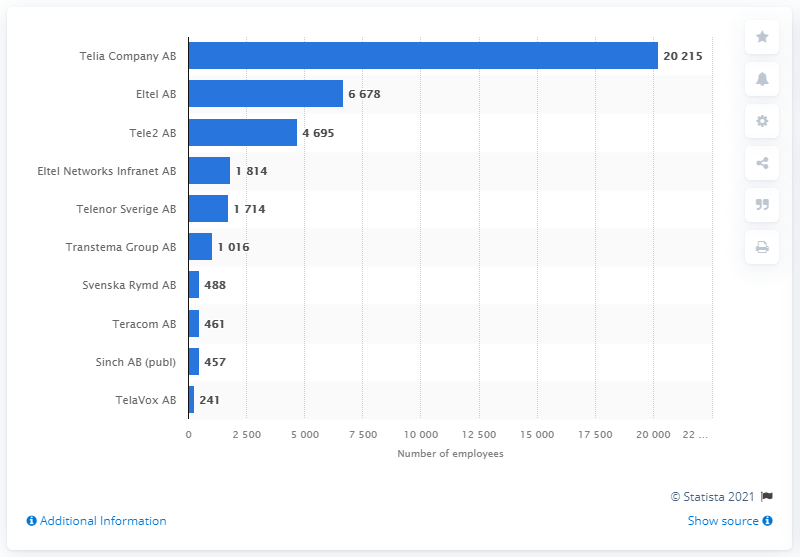Outline some significant characteristics in this image. Telia Company AB was the top-ranked telecommunication company in Sweden in 2021. 